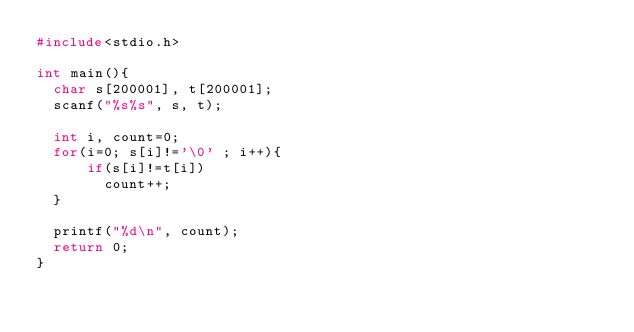<code> <loc_0><loc_0><loc_500><loc_500><_C_>#include<stdio.h>

int main(){
  char s[200001], t[200001];
  scanf("%s%s", s, t);

  int i, count=0;
  for(i=0; s[i]!='\0' ; i++){
      if(s[i]!=t[i])
        count++;
  }

  printf("%d\n", count);
  return 0;
}
</code> 